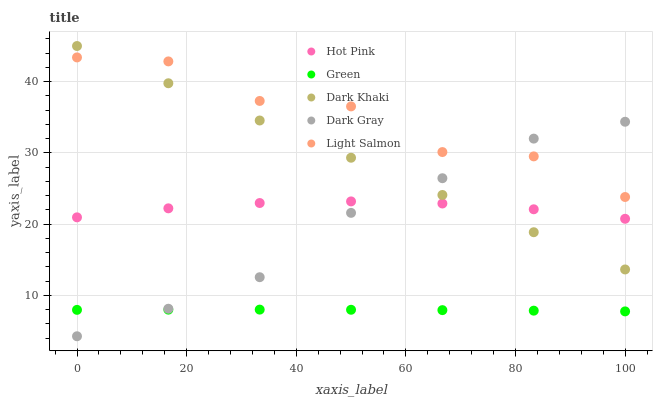Does Green have the minimum area under the curve?
Answer yes or no. Yes. Does Light Salmon have the maximum area under the curve?
Answer yes or no. Yes. Does Dark Gray have the minimum area under the curve?
Answer yes or no. No. Does Dark Gray have the maximum area under the curve?
Answer yes or no. No. Is Dark Khaki the smoothest?
Answer yes or no. Yes. Is Light Salmon the roughest?
Answer yes or no. Yes. Is Dark Gray the smoothest?
Answer yes or no. No. Is Dark Gray the roughest?
Answer yes or no. No. Does Dark Gray have the lowest value?
Answer yes or no. Yes. Does Light Salmon have the lowest value?
Answer yes or no. No. Does Dark Khaki have the highest value?
Answer yes or no. Yes. Does Dark Gray have the highest value?
Answer yes or no. No. Is Green less than Light Salmon?
Answer yes or no. Yes. Is Light Salmon greater than Green?
Answer yes or no. Yes. Does Dark Khaki intersect Hot Pink?
Answer yes or no. Yes. Is Dark Khaki less than Hot Pink?
Answer yes or no. No. Is Dark Khaki greater than Hot Pink?
Answer yes or no. No. Does Green intersect Light Salmon?
Answer yes or no. No. 